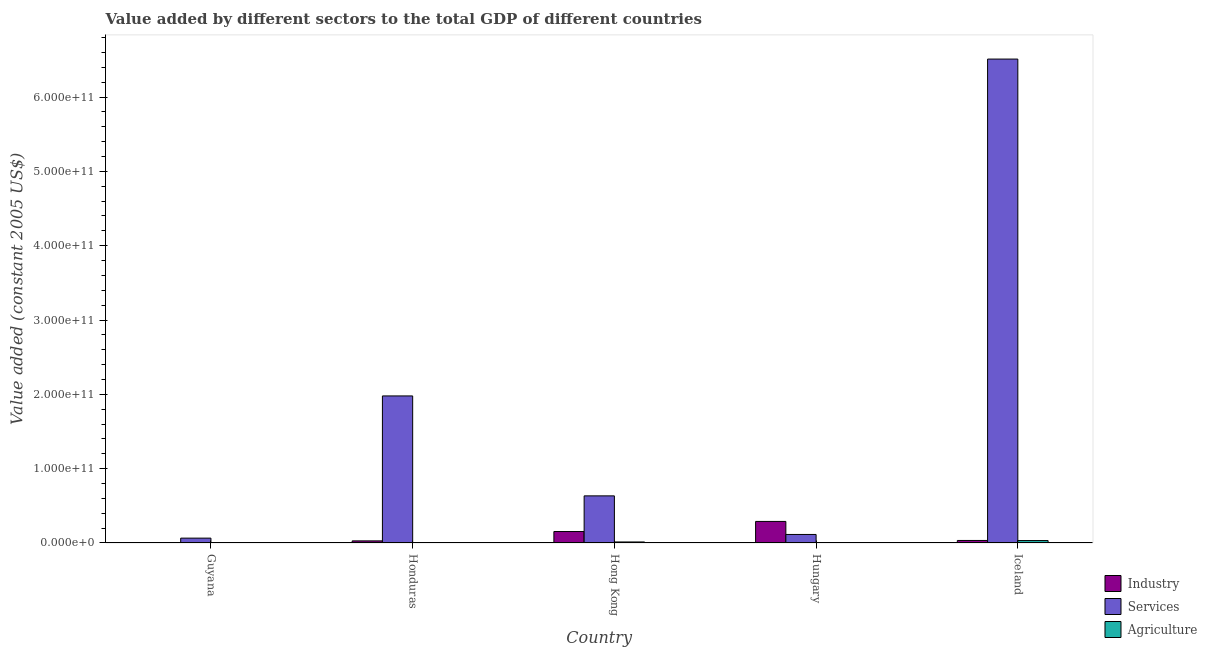How many different coloured bars are there?
Offer a terse response. 3. How many groups of bars are there?
Offer a very short reply. 5. Are the number of bars per tick equal to the number of legend labels?
Your answer should be compact. Yes. Are the number of bars on each tick of the X-axis equal?
Your answer should be very brief. Yes. How many bars are there on the 5th tick from the left?
Your answer should be compact. 3. What is the label of the 2nd group of bars from the left?
Offer a terse response. Honduras. In how many cases, is the number of bars for a given country not equal to the number of legend labels?
Provide a succinct answer. 0. What is the value added by industrial sector in Hong Kong?
Offer a terse response. 1.54e+1. Across all countries, what is the maximum value added by services?
Provide a succinct answer. 6.51e+11. Across all countries, what is the minimum value added by services?
Ensure brevity in your answer.  6.54e+09. In which country was the value added by industrial sector maximum?
Give a very brief answer. Hungary. In which country was the value added by services minimum?
Provide a short and direct response. Guyana. What is the total value added by industrial sector in the graph?
Your answer should be very brief. 5.08e+1. What is the difference between the value added by agricultural sector in Honduras and that in Hong Kong?
Offer a very short reply. -1.17e+09. What is the difference between the value added by agricultural sector in Guyana and the value added by services in Hungary?
Provide a succinct answer. -1.12e+1. What is the average value added by services per country?
Provide a succinct answer. 1.86e+11. What is the difference between the value added by industrial sector and value added by services in Guyana?
Offer a terse response. -6.37e+09. In how many countries, is the value added by services greater than 360000000000 US$?
Your answer should be very brief. 1. What is the ratio of the value added by services in Honduras to that in Hong Kong?
Provide a succinct answer. 3.12. Is the difference between the value added by services in Hong Kong and Hungary greater than the difference between the value added by agricultural sector in Hong Kong and Hungary?
Provide a succinct answer. Yes. What is the difference between the highest and the second highest value added by industrial sector?
Provide a succinct answer. 1.36e+1. What is the difference between the highest and the lowest value added by industrial sector?
Your answer should be compact. 2.88e+1. What does the 2nd bar from the left in Guyana represents?
Provide a succinct answer. Services. What does the 3rd bar from the right in Hong Kong represents?
Provide a short and direct response. Industry. Is it the case that in every country, the sum of the value added by industrial sector and value added by services is greater than the value added by agricultural sector?
Keep it short and to the point. Yes. Are all the bars in the graph horizontal?
Give a very brief answer. No. How many countries are there in the graph?
Ensure brevity in your answer.  5. What is the difference between two consecutive major ticks on the Y-axis?
Offer a very short reply. 1.00e+11. Does the graph contain grids?
Ensure brevity in your answer.  No. Where does the legend appear in the graph?
Offer a very short reply. Bottom right. What is the title of the graph?
Your response must be concise. Value added by different sectors to the total GDP of different countries. Does "Services" appear as one of the legend labels in the graph?
Your answer should be compact. Yes. What is the label or title of the X-axis?
Your response must be concise. Country. What is the label or title of the Y-axis?
Provide a short and direct response. Value added (constant 2005 US$). What is the Value added (constant 2005 US$) in Industry in Guyana?
Give a very brief answer. 1.73e+08. What is the Value added (constant 2005 US$) of Services in Guyana?
Give a very brief answer. 6.54e+09. What is the Value added (constant 2005 US$) in Agriculture in Guyana?
Offer a terse response. 2.79e+08. What is the Value added (constant 2005 US$) in Industry in Honduras?
Ensure brevity in your answer.  2.83e+09. What is the Value added (constant 2005 US$) in Services in Honduras?
Your response must be concise. 1.98e+11. What is the Value added (constant 2005 US$) of Agriculture in Honduras?
Offer a very short reply. 2.24e+08. What is the Value added (constant 2005 US$) in Industry in Hong Kong?
Your response must be concise. 1.54e+1. What is the Value added (constant 2005 US$) in Services in Hong Kong?
Offer a very short reply. 6.34e+1. What is the Value added (constant 2005 US$) in Agriculture in Hong Kong?
Your answer should be compact. 1.39e+09. What is the Value added (constant 2005 US$) of Industry in Hungary?
Give a very brief answer. 2.90e+1. What is the Value added (constant 2005 US$) of Services in Hungary?
Make the answer very short. 1.15e+1. What is the Value added (constant 2005 US$) in Agriculture in Hungary?
Ensure brevity in your answer.  9.32e+07. What is the Value added (constant 2005 US$) in Industry in Iceland?
Give a very brief answer. 3.39e+09. What is the Value added (constant 2005 US$) in Services in Iceland?
Keep it short and to the point. 6.51e+11. What is the Value added (constant 2005 US$) of Agriculture in Iceland?
Make the answer very short. 3.28e+09. Across all countries, what is the maximum Value added (constant 2005 US$) of Industry?
Make the answer very short. 2.90e+1. Across all countries, what is the maximum Value added (constant 2005 US$) of Services?
Provide a short and direct response. 6.51e+11. Across all countries, what is the maximum Value added (constant 2005 US$) of Agriculture?
Keep it short and to the point. 3.28e+09. Across all countries, what is the minimum Value added (constant 2005 US$) of Industry?
Offer a very short reply. 1.73e+08. Across all countries, what is the minimum Value added (constant 2005 US$) in Services?
Your answer should be very brief. 6.54e+09. Across all countries, what is the minimum Value added (constant 2005 US$) in Agriculture?
Your response must be concise. 9.32e+07. What is the total Value added (constant 2005 US$) of Industry in the graph?
Provide a succinct answer. 5.08e+1. What is the total Value added (constant 2005 US$) of Services in the graph?
Provide a succinct answer. 9.30e+11. What is the total Value added (constant 2005 US$) of Agriculture in the graph?
Provide a short and direct response. 5.26e+09. What is the difference between the Value added (constant 2005 US$) of Industry in Guyana and that in Honduras?
Keep it short and to the point. -2.66e+09. What is the difference between the Value added (constant 2005 US$) of Services in Guyana and that in Honduras?
Ensure brevity in your answer.  -1.91e+11. What is the difference between the Value added (constant 2005 US$) of Agriculture in Guyana and that in Honduras?
Make the answer very short. 5.50e+07. What is the difference between the Value added (constant 2005 US$) in Industry in Guyana and that in Hong Kong?
Ensure brevity in your answer.  -1.53e+1. What is the difference between the Value added (constant 2005 US$) in Services in Guyana and that in Hong Kong?
Your answer should be compact. -5.69e+1. What is the difference between the Value added (constant 2005 US$) in Agriculture in Guyana and that in Hong Kong?
Your answer should be very brief. -1.11e+09. What is the difference between the Value added (constant 2005 US$) in Industry in Guyana and that in Hungary?
Your answer should be compact. -2.88e+1. What is the difference between the Value added (constant 2005 US$) in Services in Guyana and that in Hungary?
Ensure brevity in your answer.  -4.94e+09. What is the difference between the Value added (constant 2005 US$) of Agriculture in Guyana and that in Hungary?
Provide a short and direct response. 1.85e+08. What is the difference between the Value added (constant 2005 US$) in Industry in Guyana and that in Iceland?
Your answer should be compact. -3.22e+09. What is the difference between the Value added (constant 2005 US$) of Services in Guyana and that in Iceland?
Offer a terse response. -6.45e+11. What is the difference between the Value added (constant 2005 US$) of Agriculture in Guyana and that in Iceland?
Your answer should be compact. -3.00e+09. What is the difference between the Value added (constant 2005 US$) of Industry in Honduras and that in Hong Kong?
Offer a terse response. -1.26e+1. What is the difference between the Value added (constant 2005 US$) in Services in Honduras and that in Hong Kong?
Give a very brief answer. 1.34e+11. What is the difference between the Value added (constant 2005 US$) in Agriculture in Honduras and that in Hong Kong?
Give a very brief answer. -1.17e+09. What is the difference between the Value added (constant 2005 US$) of Industry in Honduras and that in Hungary?
Offer a terse response. -2.62e+1. What is the difference between the Value added (constant 2005 US$) of Services in Honduras and that in Hungary?
Give a very brief answer. 1.86e+11. What is the difference between the Value added (constant 2005 US$) of Agriculture in Honduras and that in Hungary?
Your answer should be compact. 1.30e+08. What is the difference between the Value added (constant 2005 US$) of Industry in Honduras and that in Iceland?
Ensure brevity in your answer.  -5.61e+08. What is the difference between the Value added (constant 2005 US$) of Services in Honduras and that in Iceland?
Give a very brief answer. -4.53e+11. What is the difference between the Value added (constant 2005 US$) of Agriculture in Honduras and that in Iceland?
Ensure brevity in your answer.  -3.05e+09. What is the difference between the Value added (constant 2005 US$) in Industry in Hong Kong and that in Hungary?
Provide a succinct answer. -1.36e+1. What is the difference between the Value added (constant 2005 US$) of Services in Hong Kong and that in Hungary?
Your answer should be very brief. 5.19e+1. What is the difference between the Value added (constant 2005 US$) in Agriculture in Hong Kong and that in Hungary?
Provide a short and direct response. 1.30e+09. What is the difference between the Value added (constant 2005 US$) of Industry in Hong Kong and that in Iceland?
Provide a succinct answer. 1.20e+1. What is the difference between the Value added (constant 2005 US$) in Services in Hong Kong and that in Iceland?
Offer a terse response. -5.88e+11. What is the difference between the Value added (constant 2005 US$) of Agriculture in Hong Kong and that in Iceland?
Keep it short and to the point. -1.88e+09. What is the difference between the Value added (constant 2005 US$) in Industry in Hungary and that in Iceland?
Offer a very short reply. 2.56e+1. What is the difference between the Value added (constant 2005 US$) of Services in Hungary and that in Iceland?
Provide a short and direct response. -6.40e+11. What is the difference between the Value added (constant 2005 US$) in Agriculture in Hungary and that in Iceland?
Offer a terse response. -3.18e+09. What is the difference between the Value added (constant 2005 US$) of Industry in Guyana and the Value added (constant 2005 US$) of Services in Honduras?
Your response must be concise. -1.98e+11. What is the difference between the Value added (constant 2005 US$) of Industry in Guyana and the Value added (constant 2005 US$) of Agriculture in Honduras?
Your answer should be compact. -5.03e+07. What is the difference between the Value added (constant 2005 US$) in Services in Guyana and the Value added (constant 2005 US$) in Agriculture in Honduras?
Your answer should be very brief. 6.31e+09. What is the difference between the Value added (constant 2005 US$) in Industry in Guyana and the Value added (constant 2005 US$) in Services in Hong Kong?
Keep it short and to the point. -6.32e+1. What is the difference between the Value added (constant 2005 US$) of Industry in Guyana and the Value added (constant 2005 US$) of Agriculture in Hong Kong?
Your response must be concise. -1.22e+09. What is the difference between the Value added (constant 2005 US$) of Services in Guyana and the Value added (constant 2005 US$) of Agriculture in Hong Kong?
Give a very brief answer. 5.15e+09. What is the difference between the Value added (constant 2005 US$) in Industry in Guyana and the Value added (constant 2005 US$) in Services in Hungary?
Make the answer very short. -1.13e+1. What is the difference between the Value added (constant 2005 US$) of Industry in Guyana and the Value added (constant 2005 US$) of Agriculture in Hungary?
Your response must be concise. 8.01e+07. What is the difference between the Value added (constant 2005 US$) in Services in Guyana and the Value added (constant 2005 US$) in Agriculture in Hungary?
Keep it short and to the point. 6.45e+09. What is the difference between the Value added (constant 2005 US$) of Industry in Guyana and the Value added (constant 2005 US$) of Services in Iceland?
Provide a succinct answer. -6.51e+11. What is the difference between the Value added (constant 2005 US$) in Industry in Guyana and the Value added (constant 2005 US$) in Agriculture in Iceland?
Offer a very short reply. -3.10e+09. What is the difference between the Value added (constant 2005 US$) in Services in Guyana and the Value added (constant 2005 US$) in Agriculture in Iceland?
Your answer should be very brief. 3.26e+09. What is the difference between the Value added (constant 2005 US$) of Industry in Honduras and the Value added (constant 2005 US$) of Services in Hong Kong?
Your answer should be very brief. -6.06e+1. What is the difference between the Value added (constant 2005 US$) in Industry in Honduras and the Value added (constant 2005 US$) in Agriculture in Hong Kong?
Give a very brief answer. 1.44e+09. What is the difference between the Value added (constant 2005 US$) in Services in Honduras and the Value added (constant 2005 US$) in Agriculture in Hong Kong?
Offer a very short reply. 1.96e+11. What is the difference between the Value added (constant 2005 US$) of Industry in Honduras and the Value added (constant 2005 US$) of Services in Hungary?
Your response must be concise. -8.64e+09. What is the difference between the Value added (constant 2005 US$) in Industry in Honduras and the Value added (constant 2005 US$) in Agriculture in Hungary?
Your answer should be very brief. 2.74e+09. What is the difference between the Value added (constant 2005 US$) in Services in Honduras and the Value added (constant 2005 US$) in Agriculture in Hungary?
Offer a terse response. 1.98e+11. What is the difference between the Value added (constant 2005 US$) of Industry in Honduras and the Value added (constant 2005 US$) of Services in Iceland?
Your answer should be very brief. -6.48e+11. What is the difference between the Value added (constant 2005 US$) of Industry in Honduras and the Value added (constant 2005 US$) of Agriculture in Iceland?
Ensure brevity in your answer.  -4.45e+08. What is the difference between the Value added (constant 2005 US$) in Services in Honduras and the Value added (constant 2005 US$) in Agriculture in Iceland?
Give a very brief answer. 1.95e+11. What is the difference between the Value added (constant 2005 US$) of Industry in Hong Kong and the Value added (constant 2005 US$) of Services in Hungary?
Your answer should be compact. 3.95e+09. What is the difference between the Value added (constant 2005 US$) of Industry in Hong Kong and the Value added (constant 2005 US$) of Agriculture in Hungary?
Keep it short and to the point. 1.53e+1. What is the difference between the Value added (constant 2005 US$) of Services in Hong Kong and the Value added (constant 2005 US$) of Agriculture in Hungary?
Provide a short and direct response. 6.33e+1. What is the difference between the Value added (constant 2005 US$) of Industry in Hong Kong and the Value added (constant 2005 US$) of Services in Iceland?
Your response must be concise. -6.36e+11. What is the difference between the Value added (constant 2005 US$) of Industry in Hong Kong and the Value added (constant 2005 US$) of Agriculture in Iceland?
Offer a very short reply. 1.22e+1. What is the difference between the Value added (constant 2005 US$) of Services in Hong Kong and the Value added (constant 2005 US$) of Agriculture in Iceland?
Your answer should be compact. 6.01e+1. What is the difference between the Value added (constant 2005 US$) in Industry in Hungary and the Value added (constant 2005 US$) in Services in Iceland?
Offer a very short reply. -6.22e+11. What is the difference between the Value added (constant 2005 US$) in Industry in Hungary and the Value added (constant 2005 US$) in Agriculture in Iceland?
Make the answer very short. 2.57e+1. What is the difference between the Value added (constant 2005 US$) in Services in Hungary and the Value added (constant 2005 US$) in Agriculture in Iceland?
Keep it short and to the point. 8.20e+09. What is the average Value added (constant 2005 US$) of Industry per country?
Give a very brief answer. 1.02e+1. What is the average Value added (constant 2005 US$) of Services per country?
Ensure brevity in your answer.  1.86e+11. What is the average Value added (constant 2005 US$) in Agriculture per country?
Offer a terse response. 1.05e+09. What is the difference between the Value added (constant 2005 US$) of Industry and Value added (constant 2005 US$) of Services in Guyana?
Ensure brevity in your answer.  -6.37e+09. What is the difference between the Value added (constant 2005 US$) of Industry and Value added (constant 2005 US$) of Agriculture in Guyana?
Offer a very short reply. -1.05e+08. What is the difference between the Value added (constant 2005 US$) in Services and Value added (constant 2005 US$) in Agriculture in Guyana?
Make the answer very short. 6.26e+09. What is the difference between the Value added (constant 2005 US$) in Industry and Value added (constant 2005 US$) in Services in Honduras?
Make the answer very short. -1.95e+11. What is the difference between the Value added (constant 2005 US$) of Industry and Value added (constant 2005 US$) of Agriculture in Honduras?
Your response must be concise. 2.61e+09. What is the difference between the Value added (constant 2005 US$) in Services and Value added (constant 2005 US$) in Agriculture in Honduras?
Make the answer very short. 1.98e+11. What is the difference between the Value added (constant 2005 US$) of Industry and Value added (constant 2005 US$) of Services in Hong Kong?
Keep it short and to the point. -4.80e+1. What is the difference between the Value added (constant 2005 US$) in Industry and Value added (constant 2005 US$) in Agriculture in Hong Kong?
Offer a very short reply. 1.40e+1. What is the difference between the Value added (constant 2005 US$) of Services and Value added (constant 2005 US$) of Agriculture in Hong Kong?
Your answer should be compact. 6.20e+1. What is the difference between the Value added (constant 2005 US$) of Industry and Value added (constant 2005 US$) of Services in Hungary?
Offer a terse response. 1.75e+1. What is the difference between the Value added (constant 2005 US$) in Industry and Value added (constant 2005 US$) in Agriculture in Hungary?
Your answer should be compact. 2.89e+1. What is the difference between the Value added (constant 2005 US$) of Services and Value added (constant 2005 US$) of Agriculture in Hungary?
Your response must be concise. 1.14e+1. What is the difference between the Value added (constant 2005 US$) in Industry and Value added (constant 2005 US$) in Services in Iceland?
Give a very brief answer. -6.48e+11. What is the difference between the Value added (constant 2005 US$) in Industry and Value added (constant 2005 US$) in Agriculture in Iceland?
Provide a short and direct response. 1.17e+08. What is the difference between the Value added (constant 2005 US$) of Services and Value added (constant 2005 US$) of Agriculture in Iceland?
Make the answer very short. 6.48e+11. What is the ratio of the Value added (constant 2005 US$) in Industry in Guyana to that in Honduras?
Give a very brief answer. 0.06. What is the ratio of the Value added (constant 2005 US$) in Services in Guyana to that in Honduras?
Offer a very short reply. 0.03. What is the ratio of the Value added (constant 2005 US$) of Agriculture in Guyana to that in Honduras?
Offer a terse response. 1.25. What is the ratio of the Value added (constant 2005 US$) in Industry in Guyana to that in Hong Kong?
Your answer should be very brief. 0.01. What is the ratio of the Value added (constant 2005 US$) of Services in Guyana to that in Hong Kong?
Offer a terse response. 0.1. What is the ratio of the Value added (constant 2005 US$) in Agriculture in Guyana to that in Hong Kong?
Make the answer very short. 0.2. What is the ratio of the Value added (constant 2005 US$) of Industry in Guyana to that in Hungary?
Give a very brief answer. 0.01. What is the ratio of the Value added (constant 2005 US$) of Services in Guyana to that in Hungary?
Provide a succinct answer. 0.57. What is the ratio of the Value added (constant 2005 US$) in Agriculture in Guyana to that in Hungary?
Provide a succinct answer. 2.99. What is the ratio of the Value added (constant 2005 US$) in Industry in Guyana to that in Iceland?
Provide a succinct answer. 0.05. What is the ratio of the Value added (constant 2005 US$) of Agriculture in Guyana to that in Iceland?
Your answer should be compact. 0.09. What is the ratio of the Value added (constant 2005 US$) in Industry in Honduras to that in Hong Kong?
Make the answer very short. 0.18. What is the ratio of the Value added (constant 2005 US$) of Services in Honduras to that in Hong Kong?
Ensure brevity in your answer.  3.12. What is the ratio of the Value added (constant 2005 US$) in Agriculture in Honduras to that in Hong Kong?
Your answer should be very brief. 0.16. What is the ratio of the Value added (constant 2005 US$) of Industry in Honduras to that in Hungary?
Ensure brevity in your answer.  0.1. What is the ratio of the Value added (constant 2005 US$) of Services in Honduras to that in Hungary?
Ensure brevity in your answer.  17.24. What is the ratio of the Value added (constant 2005 US$) in Agriculture in Honduras to that in Hungary?
Give a very brief answer. 2.4. What is the ratio of the Value added (constant 2005 US$) in Industry in Honduras to that in Iceland?
Keep it short and to the point. 0.83. What is the ratio of the Value added (constant 2005 US$) of Services in Honduras to that in Iceland?
Provide a succinct answer. 0.3. What is the ratio of the Value added (constant 2005 US$) of Agriculture in Honduras to that in Iceland?
Keep it short and to the point. 0.07. What is the ratio of the Value added (constant 2005 US$) in Industry in Hong Kong to that in Hungary?
Ensure brevity in your answer.  0.53. What is the ratio of the Value added (constant 2005 US$) in Services in Hong Kong to that in Hungary?
Your answer should be very brief. 5.52. What is the ratio of the Value added (constant 2005 US$) of Agriculture in Hong Kong to that in Hungary?
Your answer should be compact. 14.94. What is the ratio of the Value added (constant 2005 US$) in Industry in Hong Kong to that in Iceland?
Ensure brevity in your answer.  4.55. What is the ratio of the Value added (constant 2005 US$) in Services in Hong Kong to that in Iceland?
Offer a terse response. 0.1. What is the ratio of the Value added (constant 2005 US$) in Agriculture in Hong Kong to that in Iceland?
Your answer should be compact. 0.43. What is the ratio of the Value added (constant 2005 US$) in Industry in Hungary to that in Iceland?
Ensure brevity in your answer.  8.55. What is the ratio of the Value added (constant 2005 US$) of Services in Hungary to that in Iceland?
Provide a short and direct response. 0.02. What is the ratio of the Value added (constant 2005 US$) of Agriculture in Hungary to that in Iceland?
Provide a short and direct response. 0.03. What is the difference between the highest and the second highest Value added (constant 2005 US$) in Industry?
Make the answer very short. 1.36e+1. What is the difference between the highest and the second highest Value added (constant 2005 US$) of Services?
Ensure brevity in your answer.  4.53e+11. What is the difference between the highest and the second highest Value added (constant 2005 US$) of Agriculture?
Keep it short and to the point. 1.88e+09. What is the difference between the highest and the lowest Value added (constant 2005 US$) of Industry?
Make the answer very short. 2.88e+1. What is the difference between the highest and the lowest Value added (constant 2005 US$) in Services?
Offer a terse response. 6.45e+11. What is the difference between the highest and the lowest Value added (constant 2005 US$) in Agriculture?
Provide a succinct answer. 3.18e+09. 